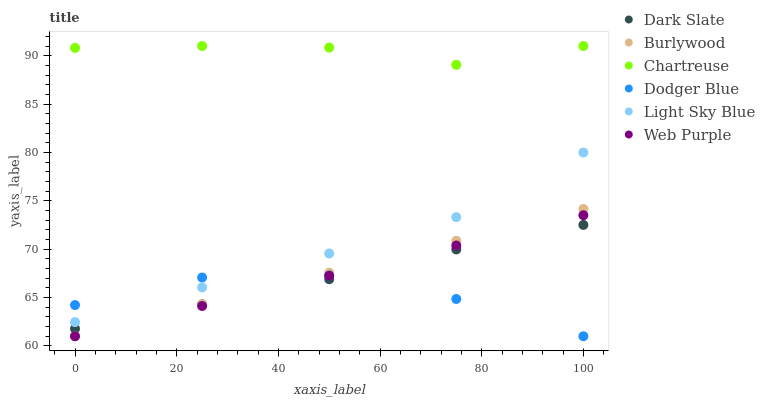Does Dodger Blue have the minimum area under the curve?
Answer yes or no. Yes. Does Chartreuse have the maximum area under the curve?
Answer yes or no. Yes. Does Web Purple have the minimum area under the curve?
Answer yes or no. No. Does Web Purple have the maximum area under the curve?
Answer yes or no. No. Is Burlywood the smoothest?
Answer yes or no. Yes. Is Dodger Blue the roughest?
Answer yes or no. Yes. Is Web Purple the smoothest?
Answer yes or no. No. Is Web Purple the roughest?
Answer yes or no. No. Does Burlywood have the lowest value?
Answer yes or no. Yes. Does Dark Slate have the lowest value?
Answer yes or no. No. Does Chartreuse have the highest value?
Answer yes or no. Yes. Does Web Purple have the highest value?
Answer yes or no. No. Is Dark Slate less than Light Sky Blue?
Answer yes or no. Yes. Is Light Sky Blue greater than Web Purple?
Answer yes or no. Yes. Does Web Purple intersect Burlywood?
Answer yes or no. Yes. Is Web Purple less than Burlywood?
Answer yes or no. No. Is Web Purple greater than Burlywood?
Answer yes or no. No. Does Dark Slate intersect Light Sky Blue?
Answer yes or no. No. 